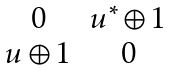Convert formula to latex. <formula><loc_0><loc_0><loc_500><loc_500>\begin{matrix} 0 & u ^ { * } \oplus 1 \\ u \oplus 1 & 0 \end{matrix}</formula> 